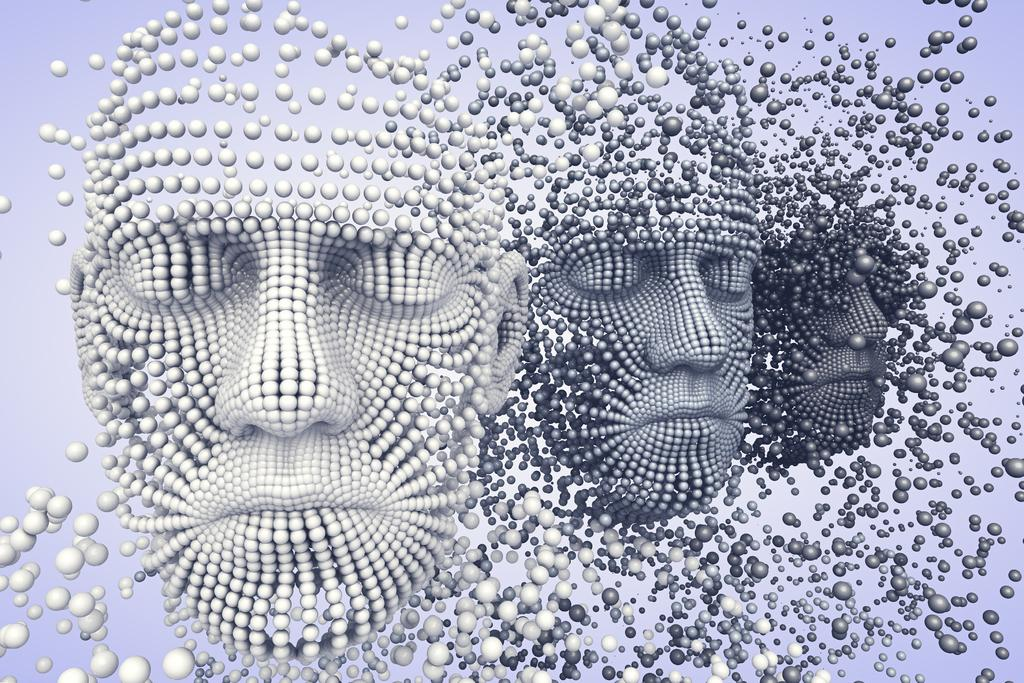What type of image is being described? The image is animated. What color is the background of the image? The background color of the image is lilac. What objects are in the middle of the image? There are three face masks in the middle of the image. What type of berry is being used as a prop in the image? There is no berry present in the image; it features an animated background and three face masks. 